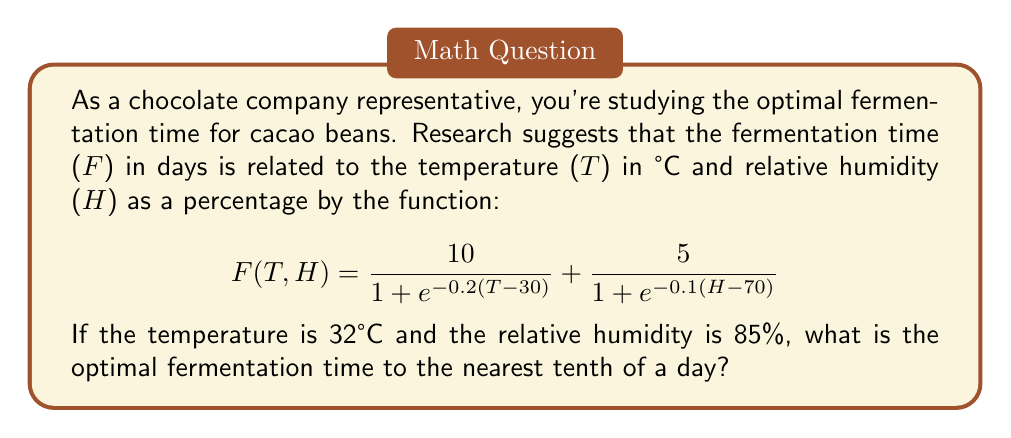Show me your answer to this math problem. To solve this problem, we need to substitute the given values into the function and calculate the result. Let's break it down step-by-step:

1. Given values:
   Temperature (T) = 32°C
   Relative Humidity (H) = 85%

2. Substitute these values into the function:

   $$F(32,85) = \frac{10}{1 + e^{-0.2(32-30)}} + \frac{5}{1 + e^{-0.1(85-70)}}$$

3. Simplify the expressions inside the exponentials:
   
   $$F(32,85) = \frac{10}{1 + e^{-0.2(2)}} + \frac{5}{1 + e^{-0.1(15)}}$$
   
   $$F(32,85) = \frac{10}{1 + e^{-0.4}} + \frac{5}{1 + e^{-1.5}}$$

4. Calculate the exponentials:
   $e^{-0.4} \approx 0.6703$
   $e^{-1.5} \approx 0.2231$

5. Substitute these values:

   $$F(32,85) = \frac{10}{1 + 0.6703} + \frac{5}{1 + 0.2231}$$

6. Perform the divisions:

   $$F(32,85) = \frac{10}{1.6703} + \frac{5}{1.2231}$$
   
   $$F(32,85) \approx 5.9868 + 4.0880$$

7. Sum the results:

   $$F(32,85) \approx 10.0748$$

8. Round to the nearest tenth:

   $$F(32,85) \approx 10.1$$

Therefore, the optimal fermentation time is approximately 10.1 days.
Answer: 10.1 days 